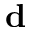<formula> <loc_0><loc_0><loc_500><loc_500>d</formula> 